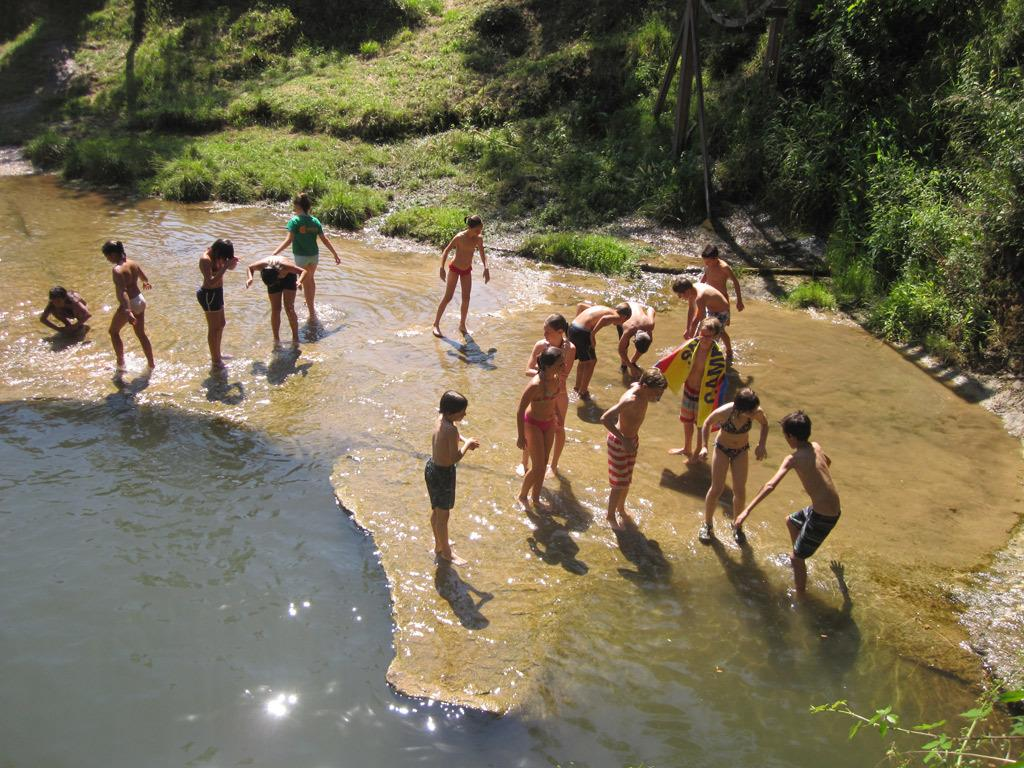What are the people in the image doing? The people in the image are standing in the water. What can be seen in the background near the water? There are trees and grass near the water. What type of quiet advice can be heard from the trees in the image? There is no quiet advice being given by the trees in the image, as trees do not speak or provide advice. 